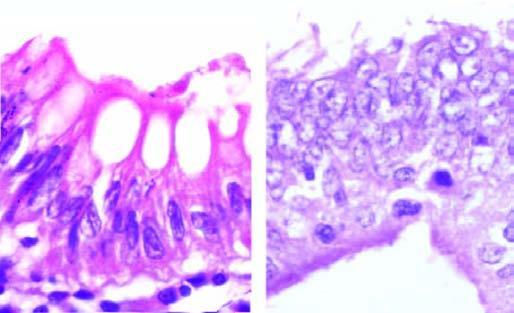s sectioned slice of the liver intact in both?
Answer the question using a single word or phrase. No 